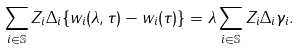Convert formula to latex. <formula><loc_0><loc_0><loc_500><loc_500>\sum _ { i \in \mathbb { S } } Z _ { i } \Delta _ { i } \{ w _ { i } ( \lambda , \tau ) - w _ { i } ( \tau ) \} = \lambda \sum _ { i \in \mathbb { S } } Z _ { i } \Delta _ { i } \gamma _ { i } .</formula> 